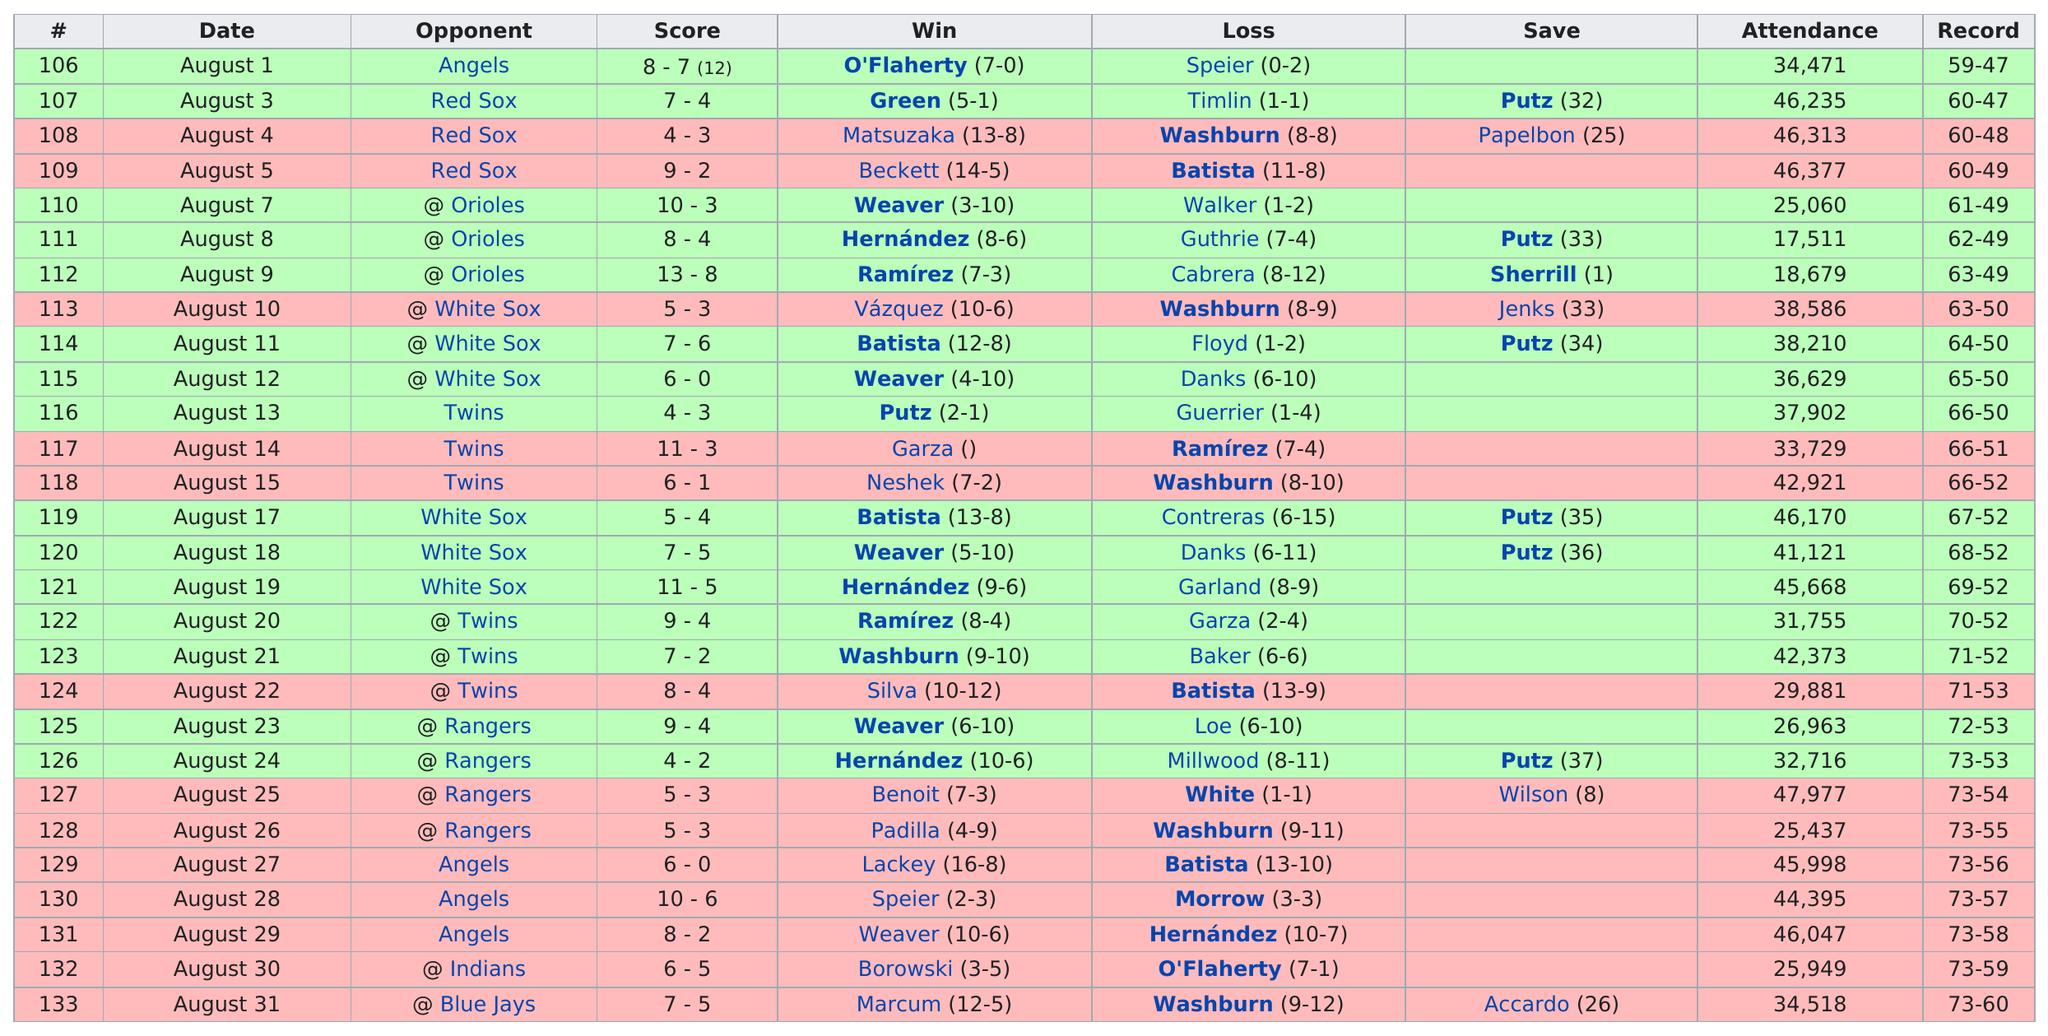Give some essential details in this illustration. There were 7 losses during the stretch. There have been 21 games with attendance above 30,000. During the winning streak, the team achieved a total of 5 wins. In August 2007, the total number of games played was 28. The largest run differential is 8. 